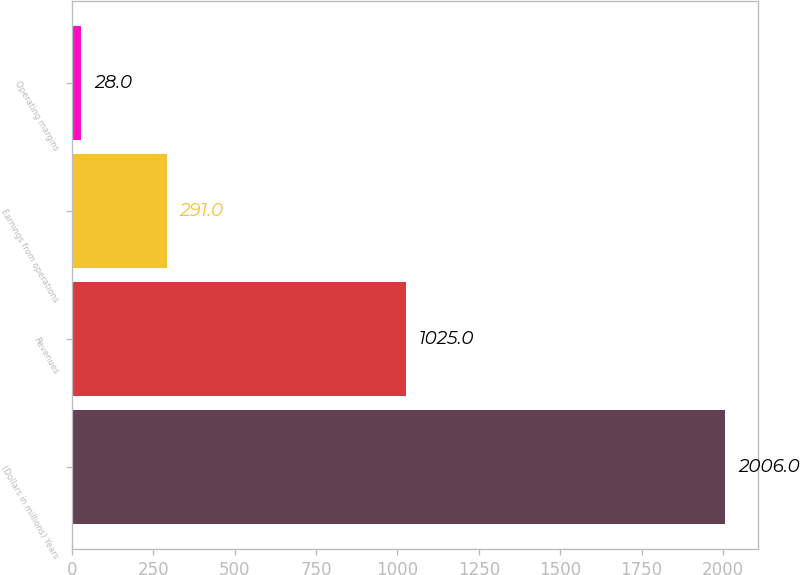Convert chart to OTSL. <chart><loc_0><loc_0><loc_500><loc_500><bar_chart><fcel>(Dollars in millions) Years<fcel>Revenues<fcel>Earnings from operations<fcel>Operating margins<nl><fcel>2006<fcel>1025<fcel>291<fcel>28<nl></chart> 